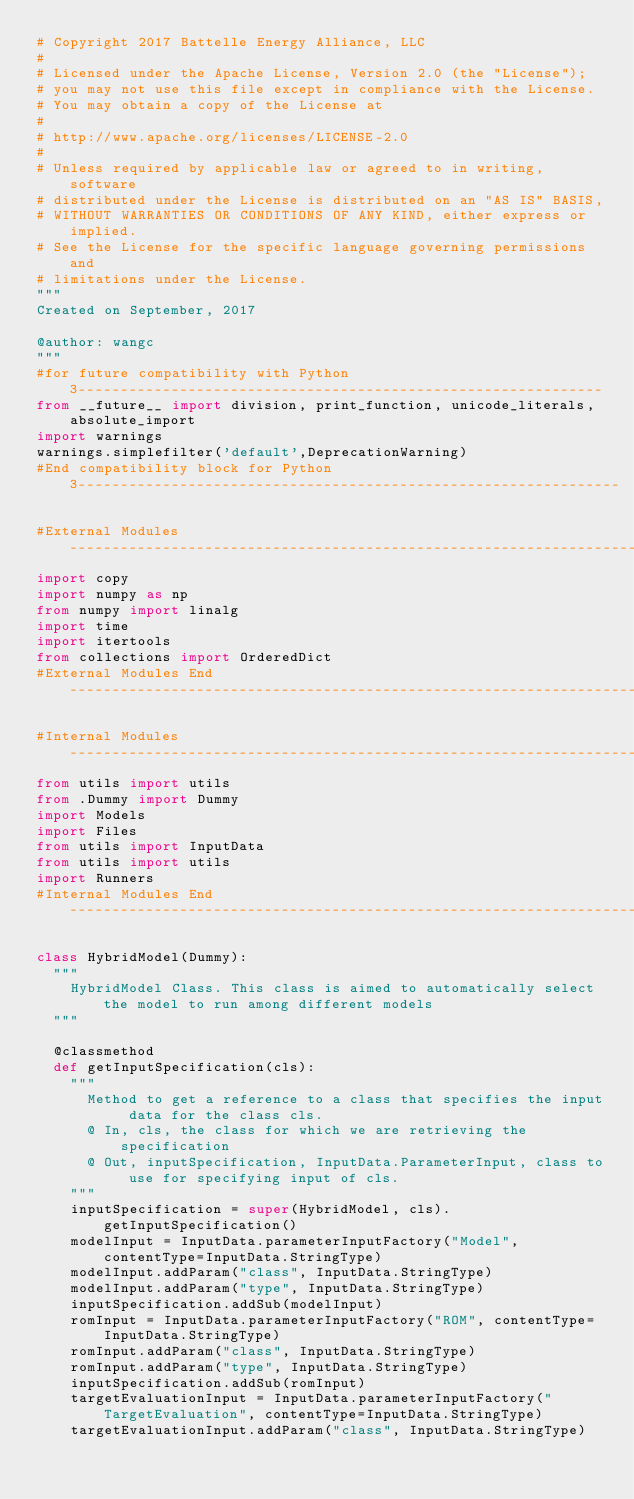<code> <loc_0><loc_0><loc_500><loc_500><_Python_># Copyright 2017 Battelle Energy Alliance, LLC
#
# Licensed under the Apache License, Version 2.0 (the "License");
# you may not use this file except in compliance with the License.
# You may obtain a copy of the License at
#
# http://www.apache.org/licenses/LICENSE-2.0
#
# Unless required by applicable law or agreed to in writing, software
# distributed under the License is distributed on an "AS IS" BASIS,
# WITHOUT WARRANTIES OR CONDITIONS OF ANY KIND, either express or implied.
# See the License for the specific language governing permissions and
# limitations under the License.
"""
Created on September, 2017

@author: wangc
"""
#for future compatibility with Python 3--------------------------------------------------------------
from __future__ import division, print_function, unicode_literals, absolute_import
import warnings
warnings.simplefilter('default',DeprecationWarning)
#End compatibility block for Python 3----------------------------------------------------------------

#External Modules------------------------------------------------------------------------------------
import copy
import numpy as np
from numpy import linalg
import time
import itertools
from collections import OrderedDict
#External Modules End--------------------------------------------------------------------------------

#Internal Modules------------------------------------------------------------------------------------
from utils import utils
from .Dummy import Dummy
import Models
import Files
from utils import InputData
from utils import utils
import Runners
#Internal Modules End--------------------------------------------------------------------------------

class HybridModel(Dummy):
  """
    HybridModel Class. This class is aimed to automatically select the model to run among different models
  """

  @classmethod
  def getInputSpecification(cls):
    """
      Method to get a reference to a class that specifies the input data for the class cls.
      @ In, cls, the class for which we are retrieving the specification
      @ Out, inputSpecification, InputData.ParameterInput, class to use for specifying input of cls.
    """
    inputSpecification = super(HybridModel, cls).getInputSpecification()
    modelInput = InputData.parameterInputFactory("Model", contentType=InputData.StringType)
    modelInput.addParam("class", InputData.StringType)
    modelInput.addParam("type", InputData.StringType)
    inputSpecification.addSub(modelInput)
    romInput = InputData.parameterInputFactory("ROM", contentType=InputData.StringType)
    romInput.addParam("class", InputData.StringType)
    romInput.addParam("type", InputData.StringType)
    inputSpecification.addSub(romInput)
    targetEvaluationInput = InputData.parameterInputFactory("TargetEvaluation", contentType=InputData.StringType)
    targetEvaluationInput.addParam("class", InputData.StringType)</code> 